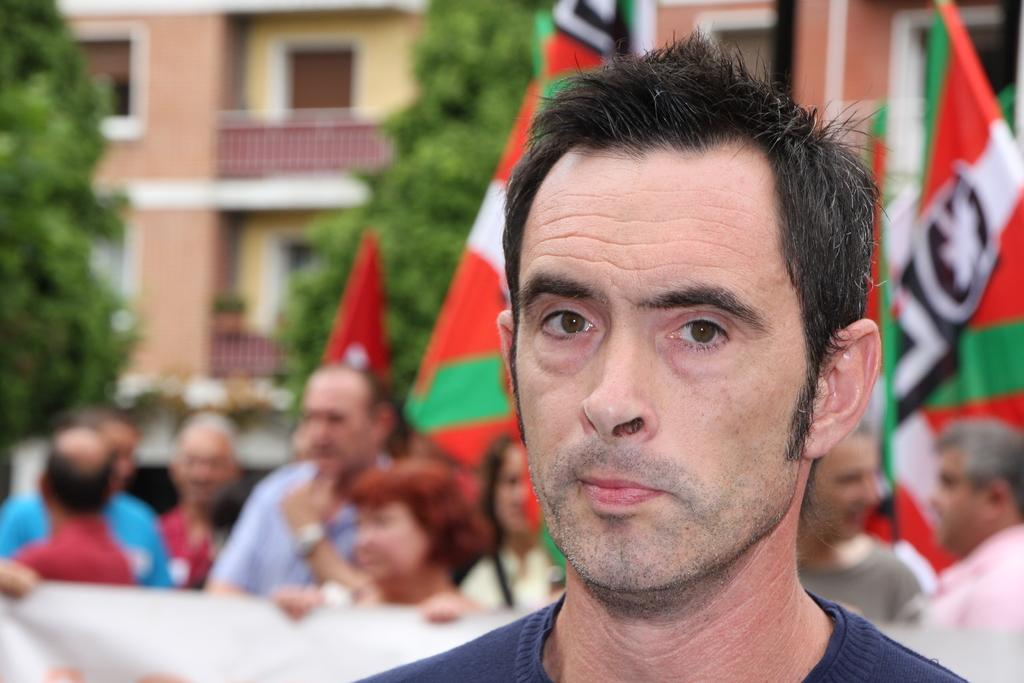What is the main subject in the middle of the image? There is a man standing in the middle of the image. What is the man doing in the image? The man is watching something. Are there any other people in the image? Yes, there are people standing behind the man. What are the people holding in the image? The people are holding flags. What can be seen in the background of the image? Trees and buildings are visible in the background. What type of yard can be seen in the image? There is no yard present in the image. What color is the coat the man is wearing in the image? The man is not wearing a coat in the image; he is wearing a shirt. 